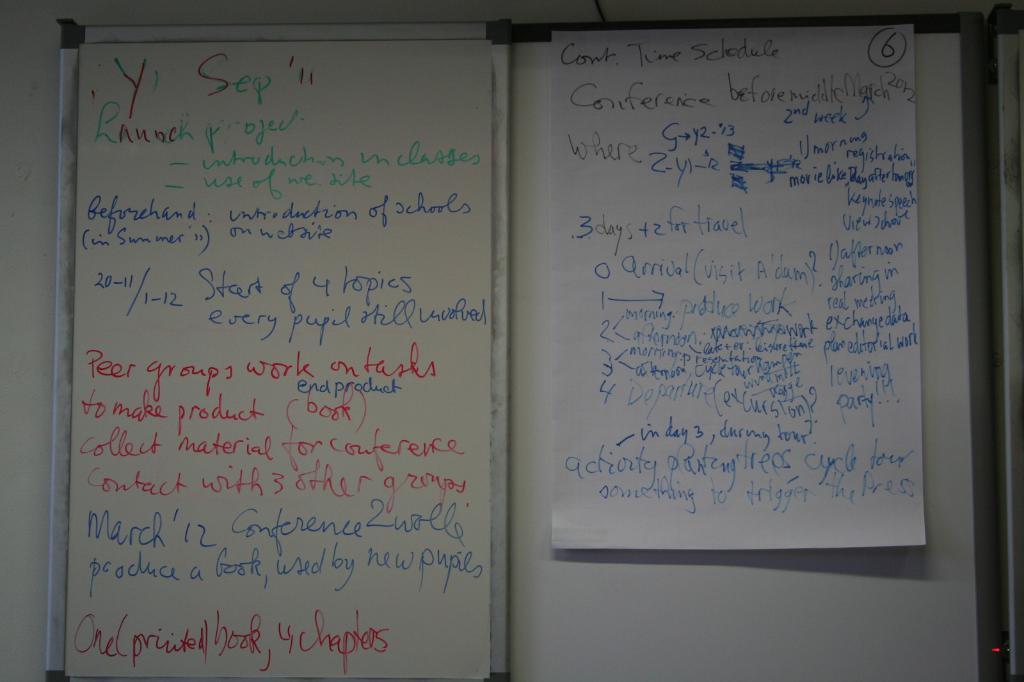What kind of time schedule is listed on the top of the second page?
Offer a terse response. Continued. 